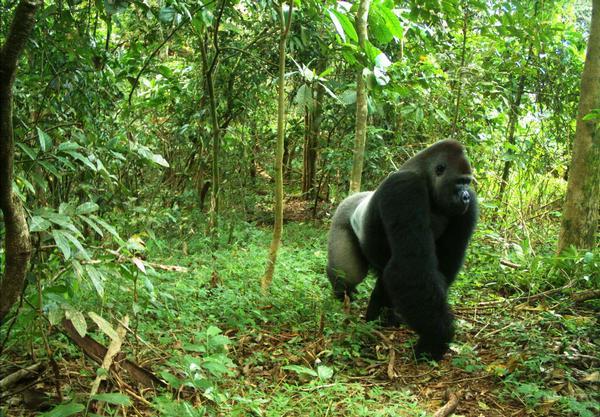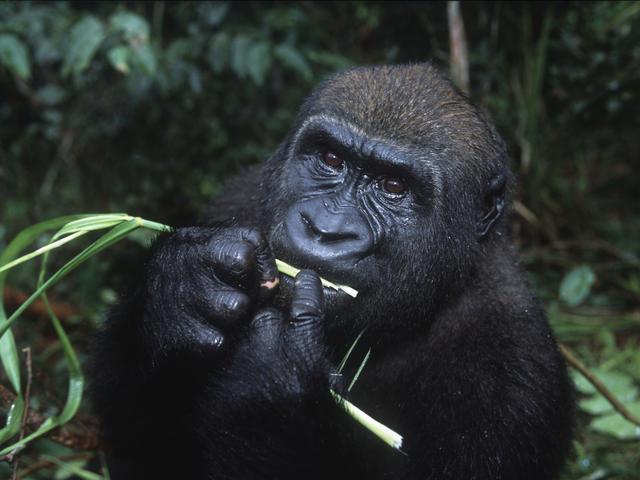The first image is the image on the left, the second image is the image on the right. For the images displayed, is the sentence "There are no more than two gorillas." factually correct? Answer yes or no. Yes. The first image is the image on the left, the second image is the image on the right. For the images shown, is this caption "There is one gorilla walking and one that is stationary while facing to the left." true? Answer yes or no. Yes. 